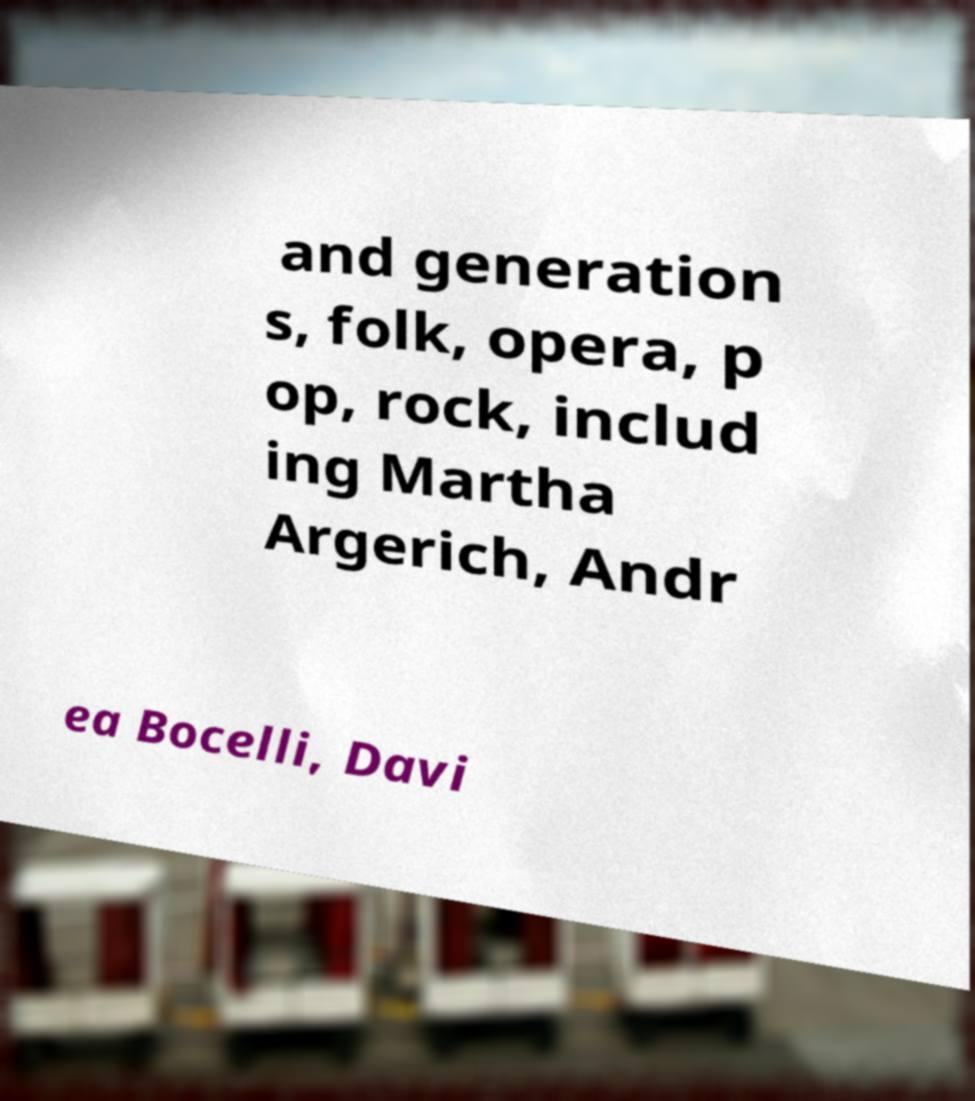Please identify and transcribe the text found in this image. and generation s, folk, opera, p op, rock, includ ing Martha Argerich, Andr ea Bocelli, Davi 